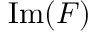<formula> <loc_0><loc_0><loc_500><loc_500>{ I m } ( F )</formula> 